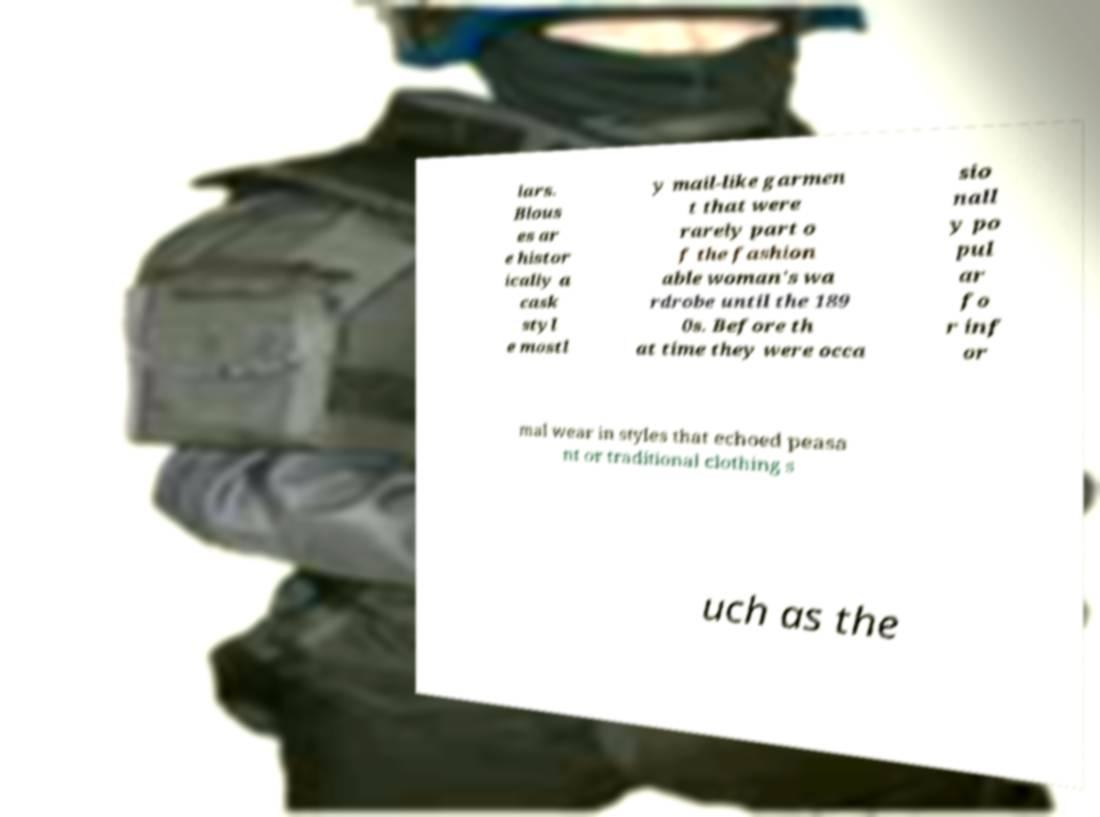Please read and relay the text visible in this image. What does it say? lars. Blous es ar e histor ically a cask styl e mostl y mail-like garmen t that were rarely part o f the fashion able woman's wa rdrobe until the 189 0s. Before th at time they were occa sio nall y po pul ar fo r inf or mal wear in styles that echoed peasa nt or traditional clothing s uch as the 